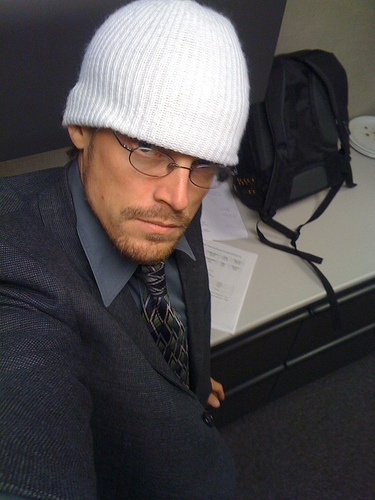Describe the objects in this image and their specific colors. I can see people in purple, black, white, brown, and gray tones, backpack in purple, black, and gray tones, and tie in purple, black, and gray tones in this image. 